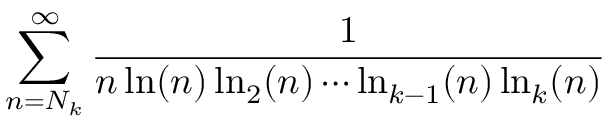Convert formula to latex. <formula><loc_0><loc_0><loc_500><loc_500>\sum _ { n = N _ { k } } ^ { \infty } { \frac { 1 } { n \ln ( n ) \ln _ { 2 } ( n ) \cdots \ln _ { k - 1 } ( n ) \ln _ { k } ( n ) } }</formula> 